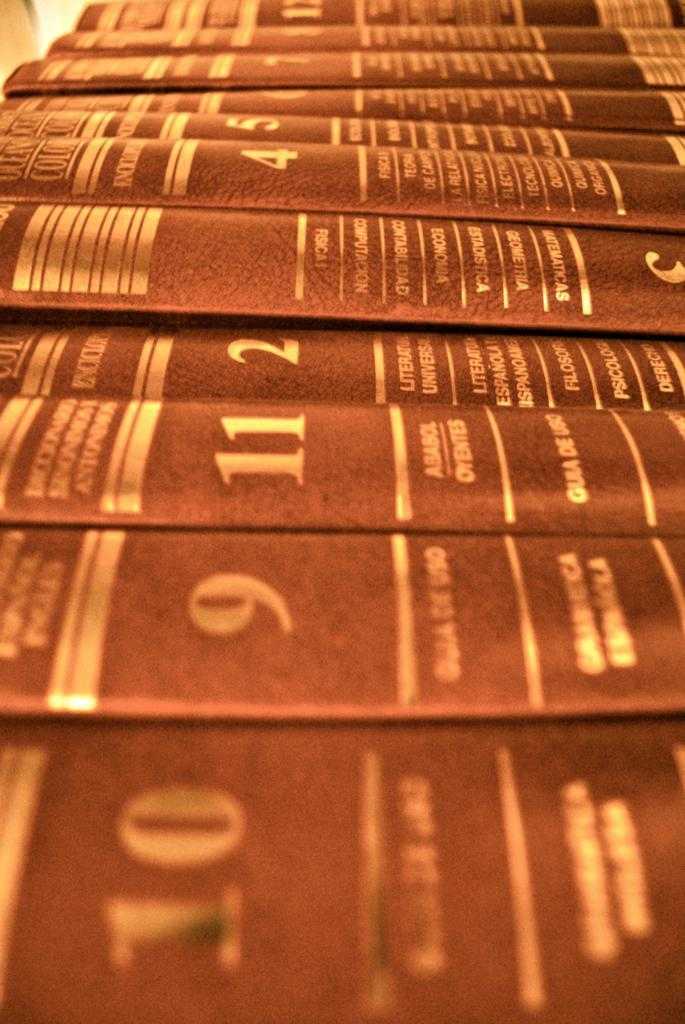<image>
Share a concise interpretation of the image provided. Volumes of a book are lined up including one called Ababol. 